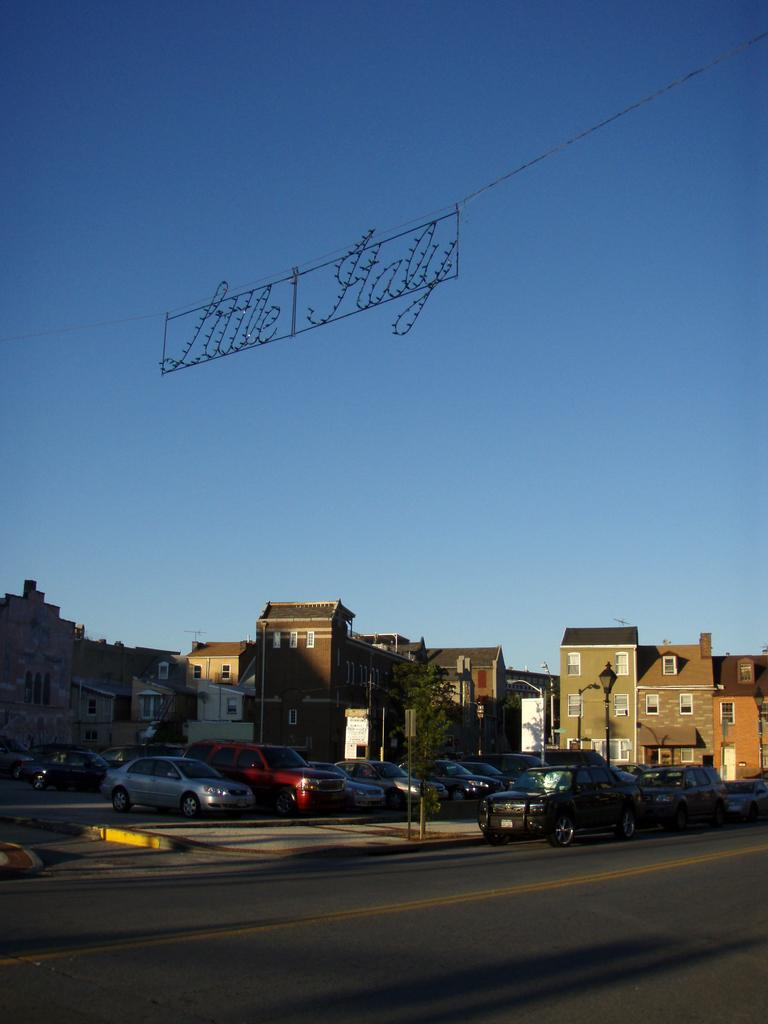What is the main feature of the image? There is a road in the image. What can be seen on the road? There are vehicles on the road. What else is present in the image besides the road and vehicles? There are poles, trees, buildings, and lights in the shape of words in the background of the image. What is visible in the background of the image? The sky is visible in the background of the image. Can you see a baseball game happening in the image? There is no baseball game present in the image. Are there any cacti visible in the image? There are no cacti present in the image. 